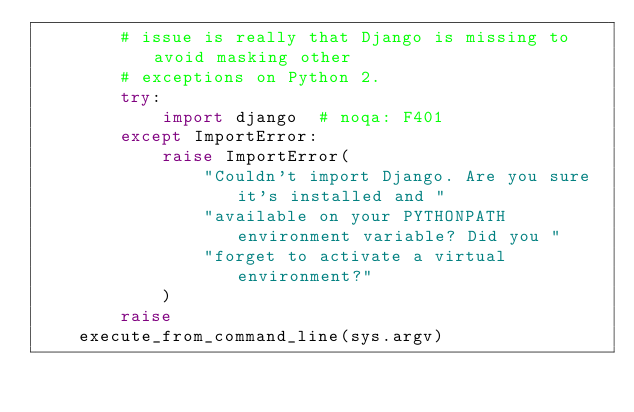Convert code to text. <code><loc_0><loc_0><loc_500><loc_500><_Python_>        # issue is really that Django is missing to avoid masking other
        # exceptions on Python 2.
        try:
            import django  # noqa: F401
        except ImportError:
            raise ImportError(
                "Couldn't import Django. Are you sure it's installed and "
                "available on your PYTHONPATH environment variable? Did you "
                "forget to activate a virtual environment?"
            )
        raise
    execute_from_command_line(sys.argv)
</code> 